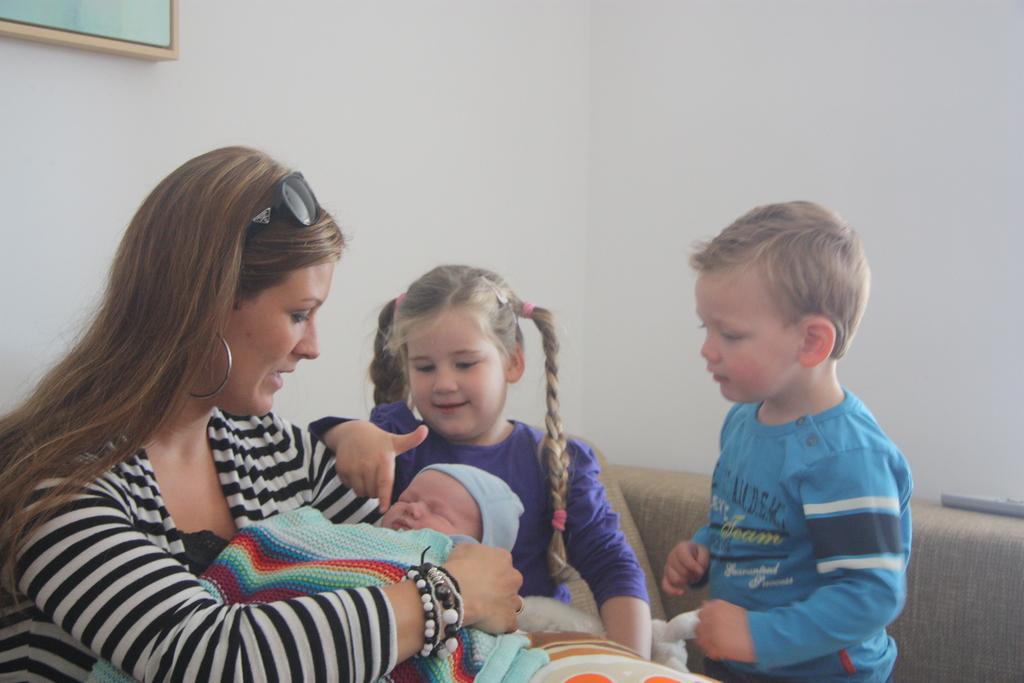Please provide a concise description of this image. In this image I can see group of people. In front the person is wearing black and white color dress and holding the baby. In the background I can see the frame attached to the wall and the wall is in white color. 